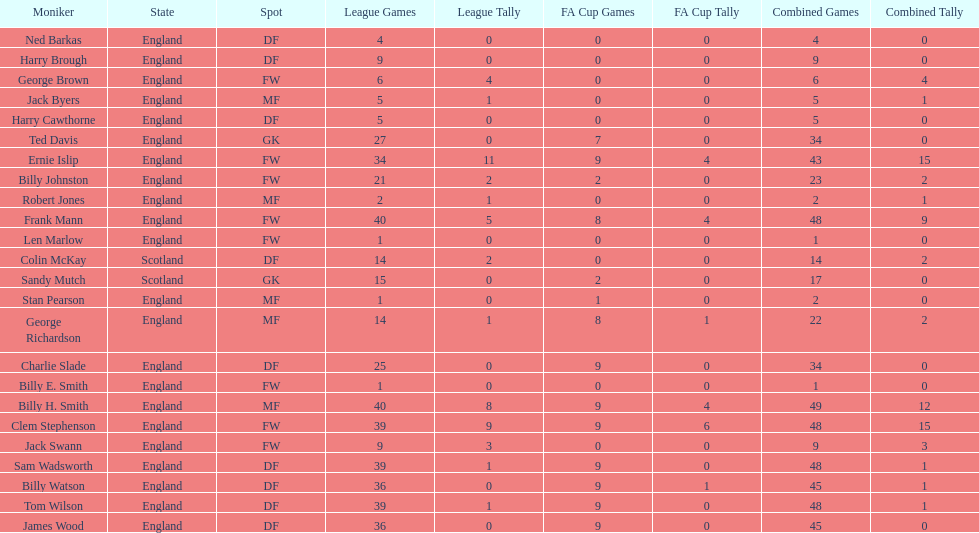What is the average number of scotland's total apps? 15.5. 